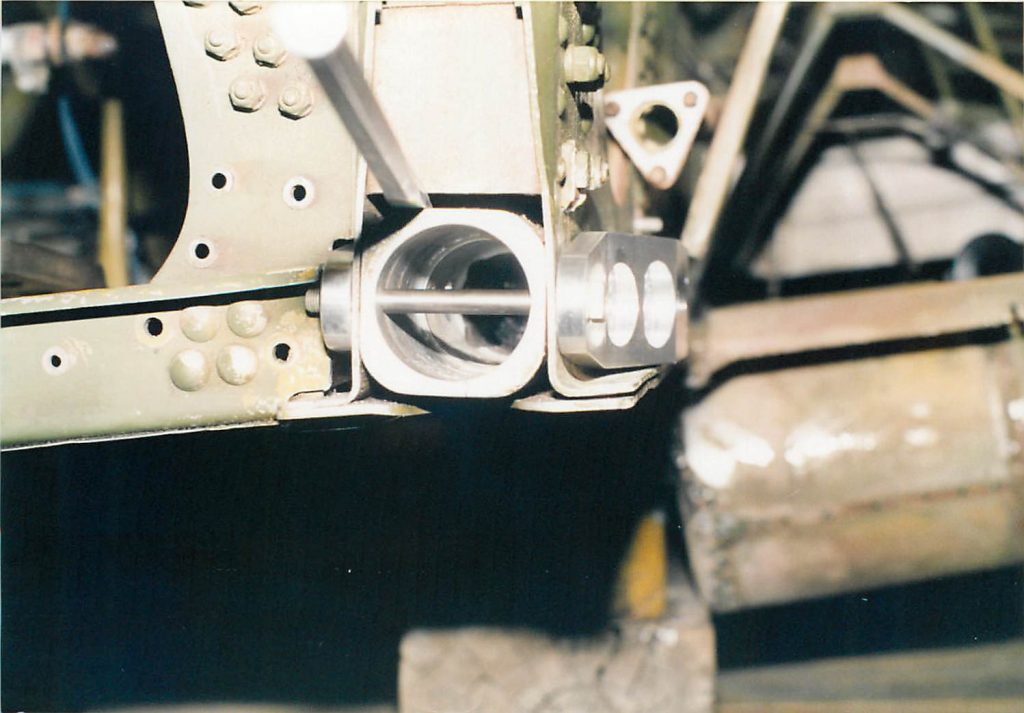Can you explain why the positioning of this pin in its assembly is critical? The positioning of the cylindrical pin is critical because it directly affects the alignment and operational integrity of the entire assembly. If improperly positioned, it could lead to mechanical failures, increased wear, and even safety hazards in critical systems such as brake assemblies in vehicles or linkage systems in industrial machinery. 